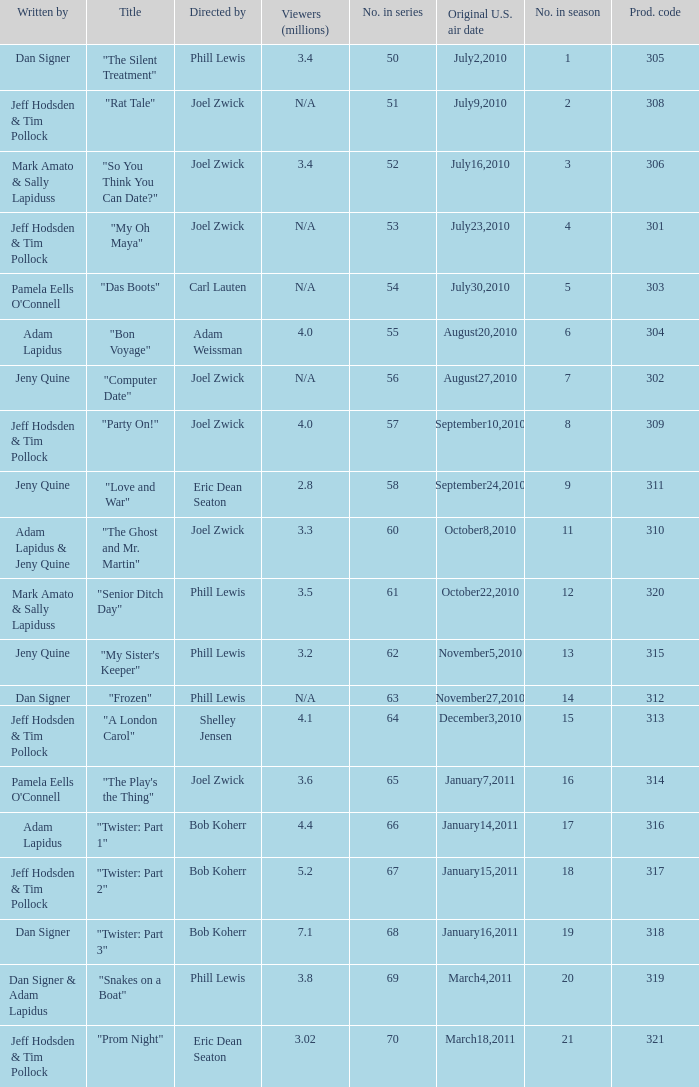Who was the directed for the episode titled "twister: part 1"? Bob Koherr. 